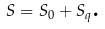Convert formula to latex. <formula><loc_0><loc_0><loc_500><loc_500>S = S _ { 0 } + S _ { q } \text {.}</formula> 